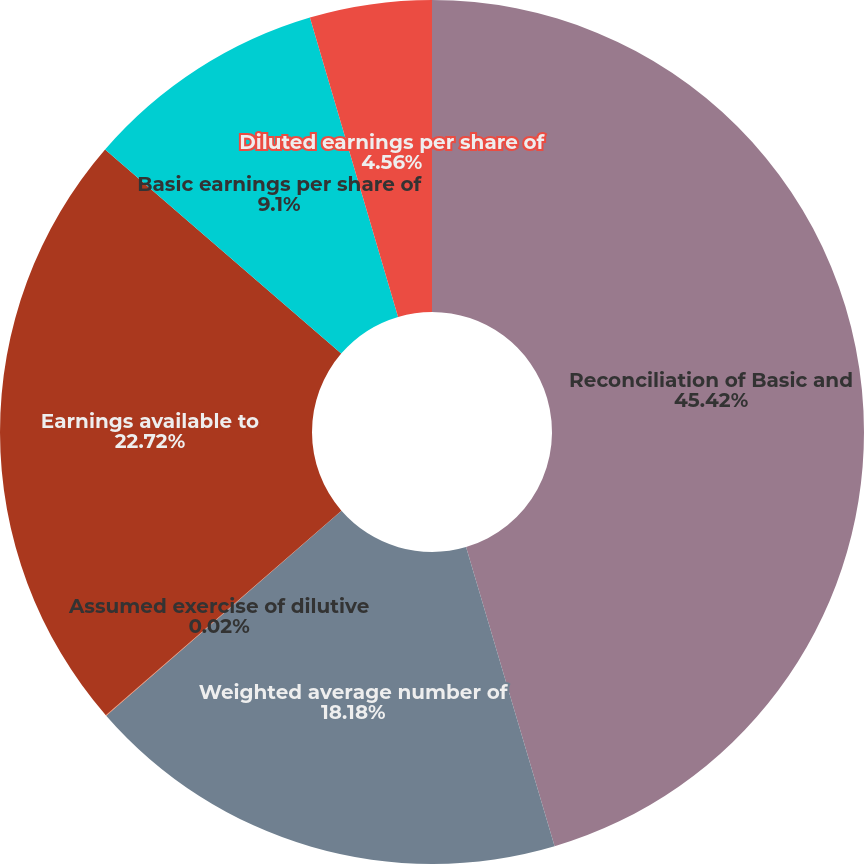Convert chart to OTSL. <chart><loc_0><loc_0><loc_500><loc_500><pie_chart><fcel>Reconciliation of Basic and<fcel>Weighted average number of<fcel>Assumed exercise of dilutive<fcel>Earnings available to<fcel>Basic earnings per share of<fcel>Diluted earnings per share of<nl><fcel>45.42%<fcel>18.18%<fcel>0.02%<fcel>22.72%<fcel>9.1%<fcel>4.56%<nl></chart> 